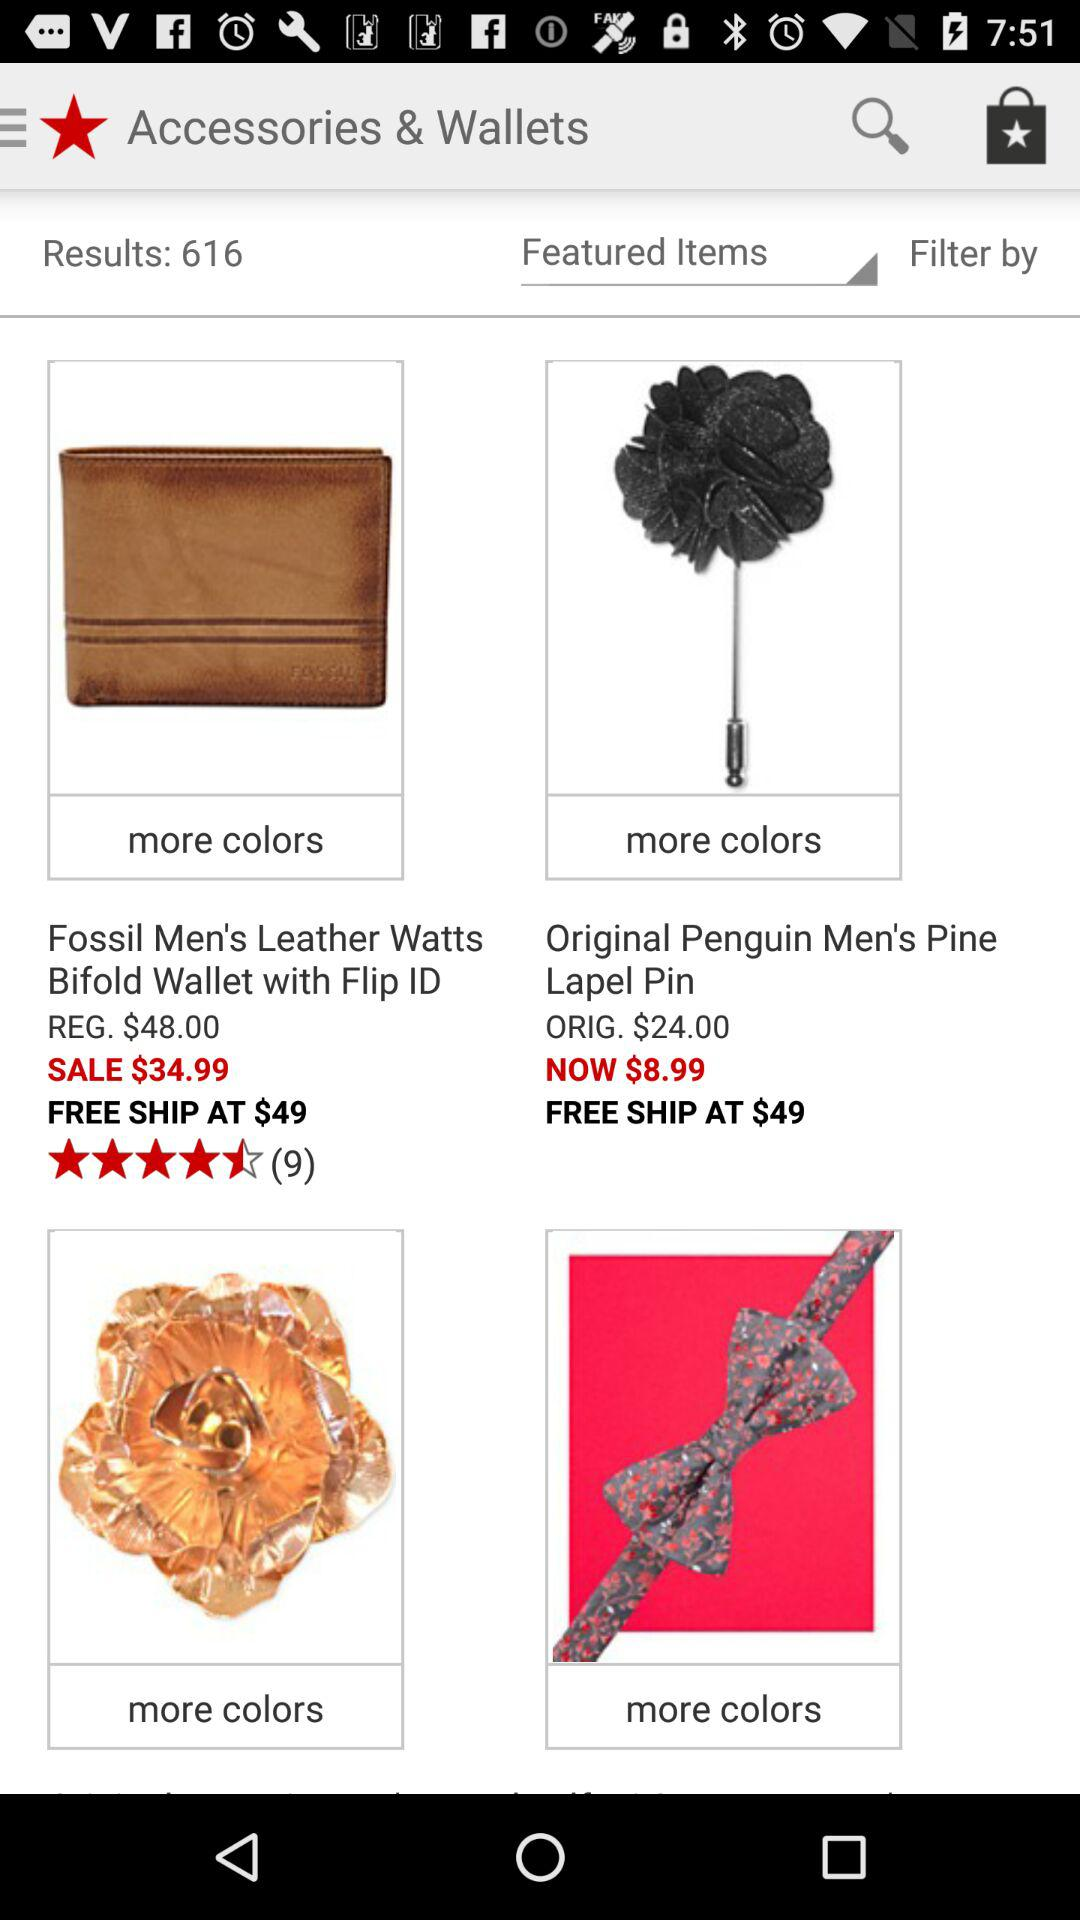At what price can the free shipping be availed of? At a price of $49, free shipping is available. 